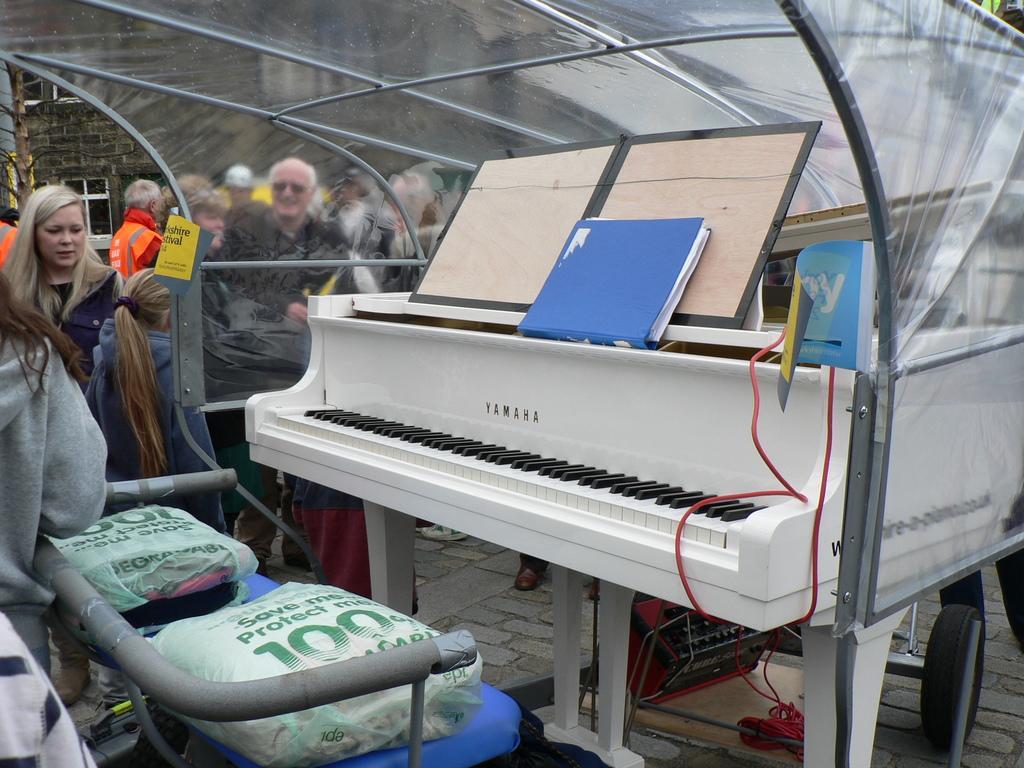Can you describe this image briefly? There is a piano in the given picture. In front of a piano there are two seats for sitting. On the piano, there is a file and in the background we can observe some people here. 